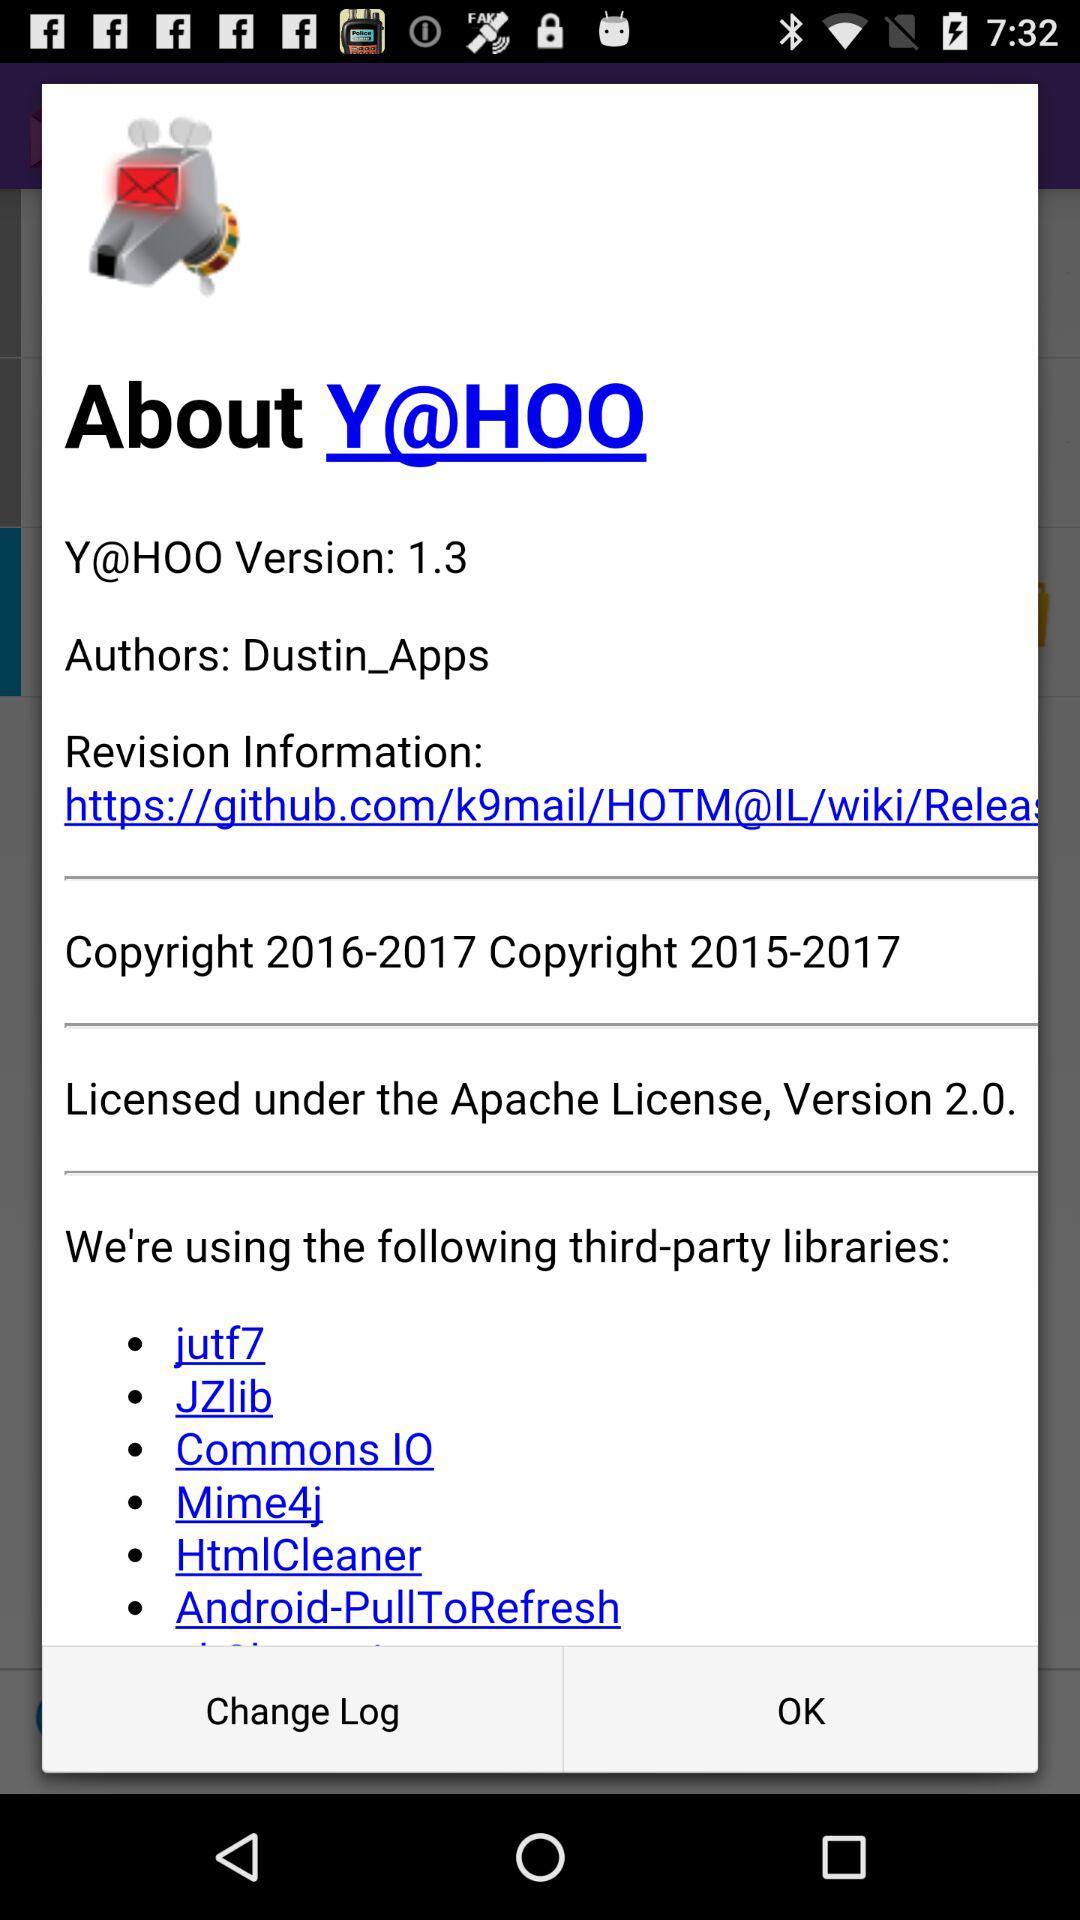What is the purpose of including third-party libraries in software? Third-party libraries are included in software to leverage existing solutions for common problems, enhance functionality, and accelerate development by not having to reinvent the wheel for standard operations. 